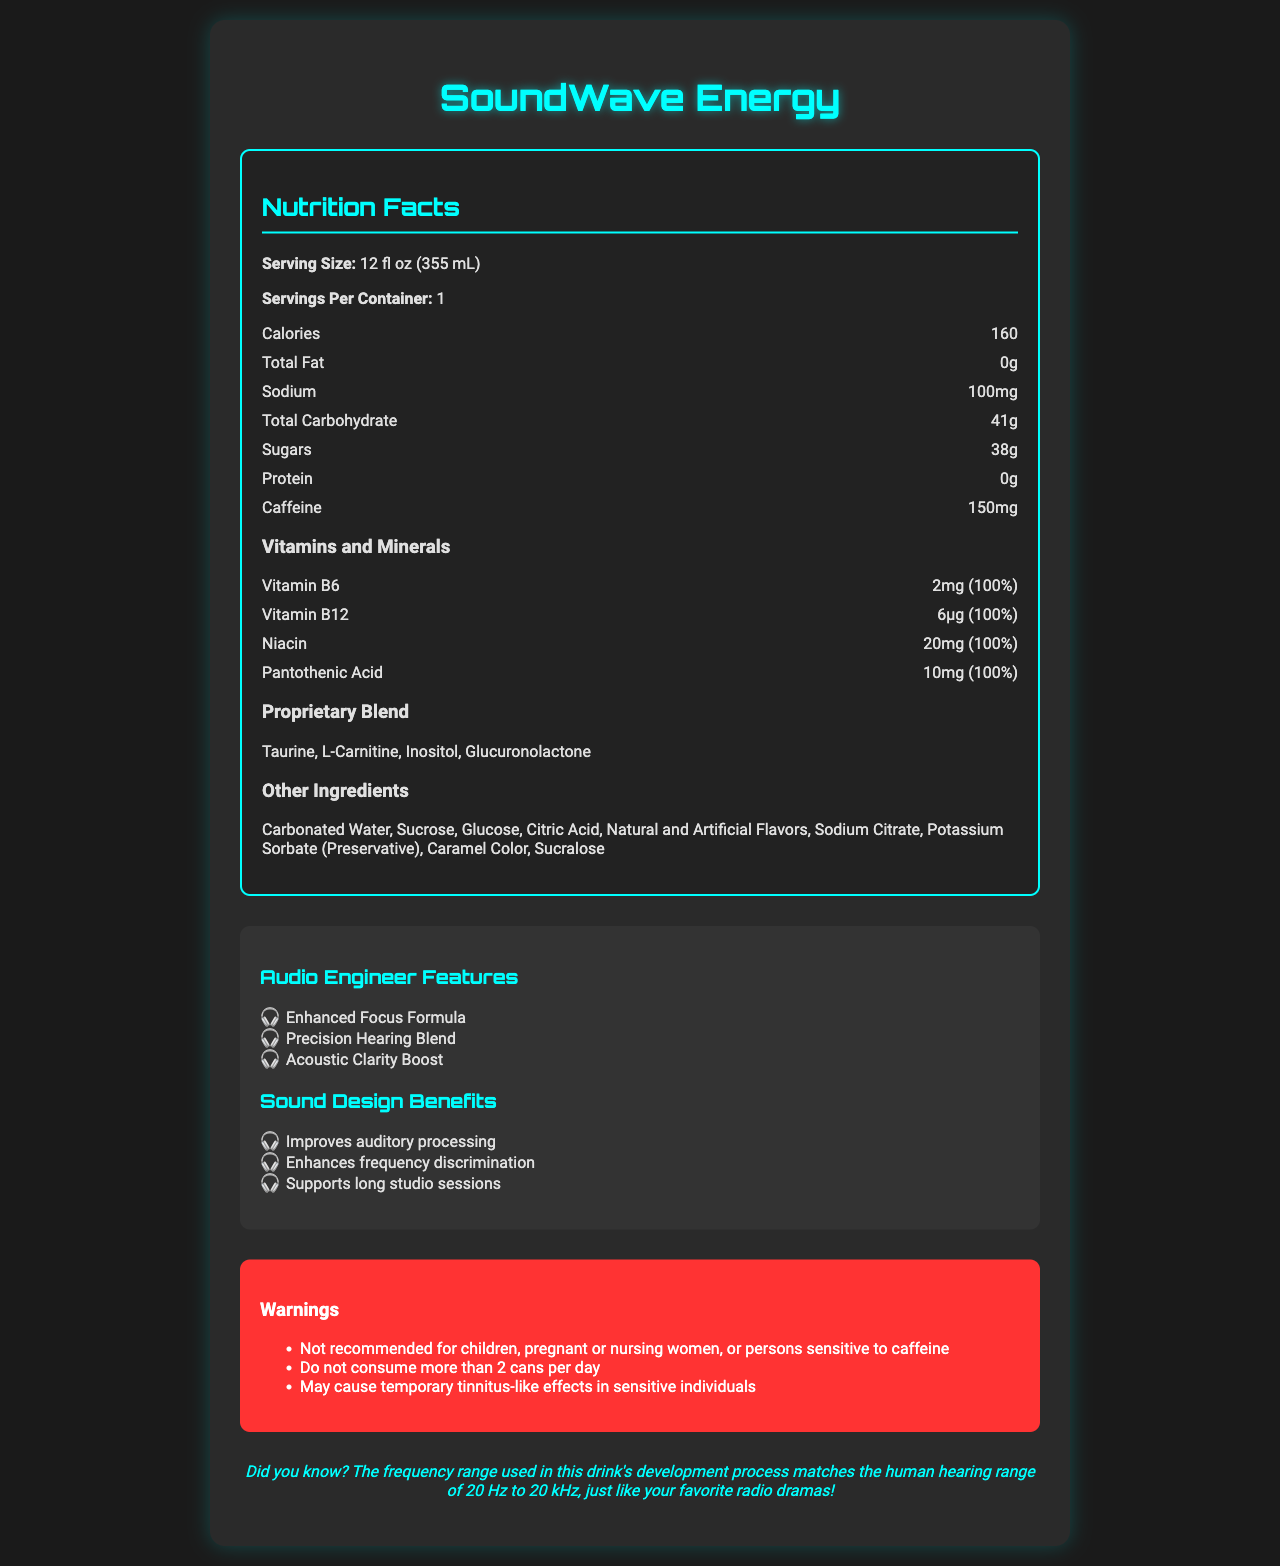what is the serving size of SoundWave Energy? The serving size is explicitly mentioned in the document under "Serving Size".
Answer: 12 fl oz (355 mL) how much caffeine does a can of SoundWave Energy contain? The caffeine content is clearly listed in the nutrition facts under "Caffeine".
Answer: 150mg what are the benefits for sound designers mentioned in the document? These benefits are listed under the "Sound Design Benefits" section of the document.
Answer: Improves auditory processing, Enhances frequency discrimination, Supports long studio sessions how much sodium is in a serving of SoundWave Energy? The sodium content is listed in the nutrition facts section under "Sodium".
Answer: 100mg how many servings are in a container of SoundWave Energy? The number of servings per container is listed as "1" under "Servings Per Container".
Answer: 1 which of the following vitamins are present in SoundWave Energy? A. Vitamin A B. Vitamin B6 C. Vitamin C D. Vitamin D The nutrition facts list Vitamin B6 as one of the vitamins present, but Vitamins A, C, and D are not mentioned.
Answer: B. Vitamin B6 what daily value percentage of Niacin does SoundWave Energy provide? A. 50% B. 75% C. 100% D. 150% The document states that Niacin is provided at 20mg, which is 100% of the daily value.
Answer: C. 100% is the amount of protein in SoundWave Energy significant? The document lists the amount of protein as "0g", indicating it is insignificant.
Answer: No does SoundWave Energy contain any artificial flavors? "Natural and Artificial Flavors" are listed under the "Other Ingredients" section.
Answer: Yes what proprietary blend ingredients are included in SoundWave Energy? The proprietary blend ingredients are listed under "Proprietary Blend".
Answer: Taurine, L-Carnitine, Inositol, Glucuronolactone are the calories in SoundWave Energy high relative to its serving size? The document states that there are 160 calories per serving, but it does not provide context to compare against, making it difficult to determine if this is high or not.
Answer: Not enough information what are some of the audio engineer features of SoundWave Energy? These features are listed under the "Audio Engineer Features" section of the document.
Answer: Enhanced Focus Formula, Precision Hearing Blend, Acoustic Clarity Boost what is the main idea of the SoundWave Energy Nutrition Facts document? The document aims to describe the nutritional content and the specific benefits and warnings associated with SoundWave Energy, with a focus on its utility for audio professionals.
Answer: The document provides detailed nutritional information about SoundWave Energy, an energy drink marketed towards audio engineers and sound designers, highlighting its ingredients, vitamins, and benefits related to auditory processing and studio work, as well as various warnings. 